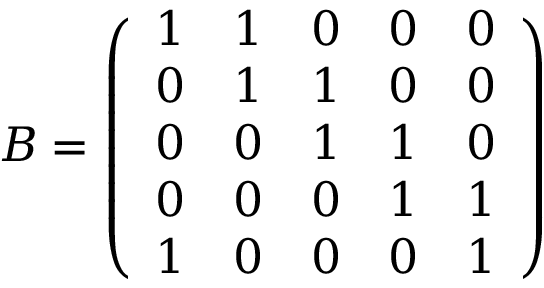Convert formula to latex. <formula><loc_0><loc_0><loc_500><loc_500>B = \left ( \begin{array} { l l l l l } { 1 } & { 1 } & { 0 } & { 0 } & { 0 } \\ { 0 } & { 1 } & { 1 } & { 0 } & { 0 } \\ { 0 } & { 0 } & { 1 } & { 1 } & { 0 } \\ { 0 } & { 0 } & { 0 } & { 1 } & { 1 } \\ { 1 } & { 0 } & { 0 } & { 0 } & { 1 } \end{array} \right )</formula> 